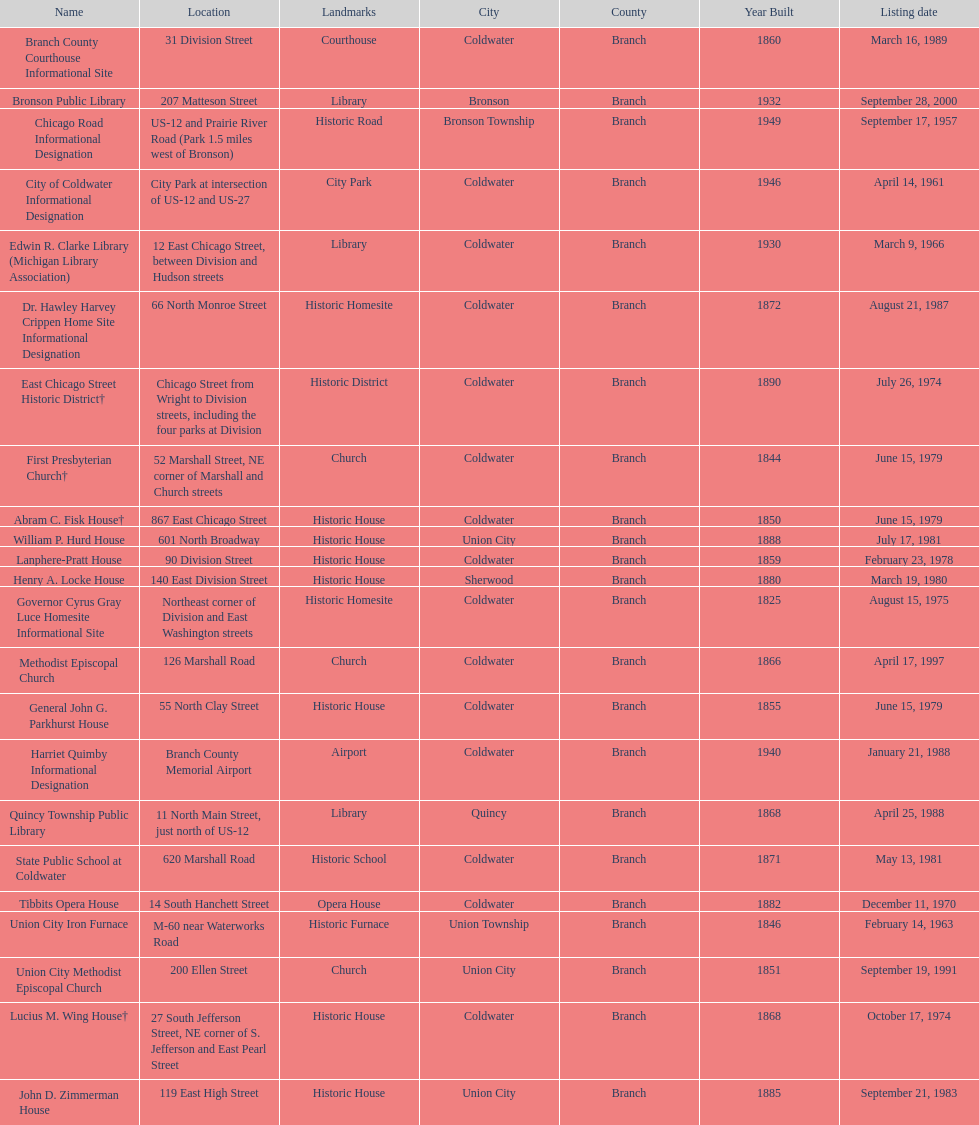Name a site that was listed no later than 1960. Chicago Road Informational Designation. 